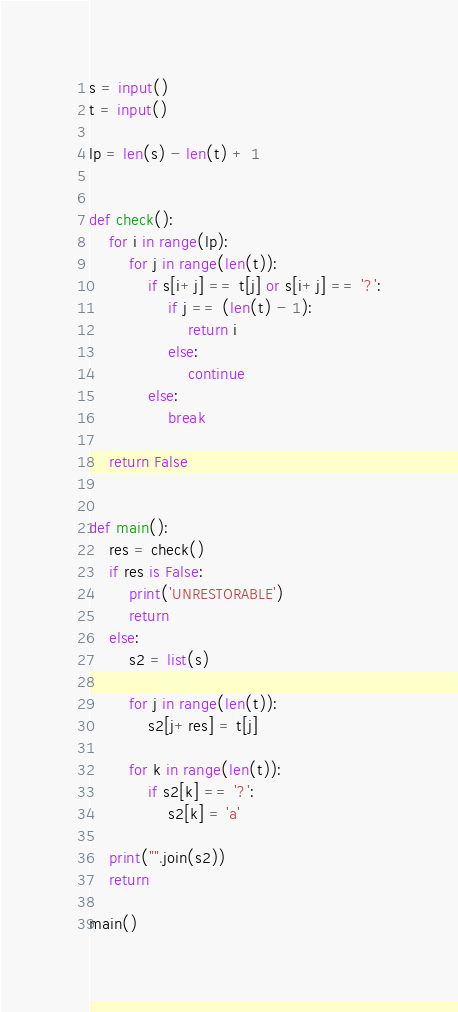Convert code to text. <code><loc_0><loc_0><loc_500><loc_500><_Python_>s = input()
t = input()

lp = len(s) - len(t) + 1


def check():
    for i in range(lp):
        for j in range(len(t)):
            if s[i+j] == t[j] or s[i+j] == '?':
                if j == (len(t) - 1):
                    return i
                else:
                    continue
            else:
                break

    return False


def main():
    res = check()
    if res is False:
        print('UNRESTORABLE')
        return
    else:
        s2 = list(s)

        for j in range(len(t)):
            s2[j+res] = t[j]

        for k in range(len(t)):
            if s2[k] == '?':
                s2[k] = 'a'

    print("".join(s2))
    return

main()</code> 